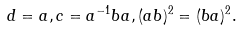<formula> <loc_0><loc_0><loc_500><loc_500>d = a , c = a ^ { - 1 } b a , ( a b ) ^ { 2 } = ( b a ) ^ { 2 } .</formula> 